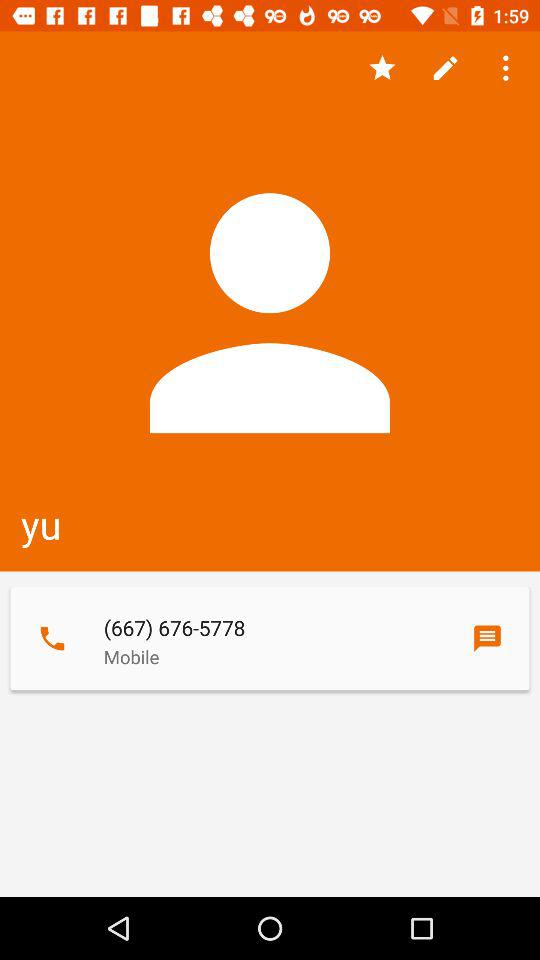What is the given mobile number? The given mobile number is (667) 676-5778. 